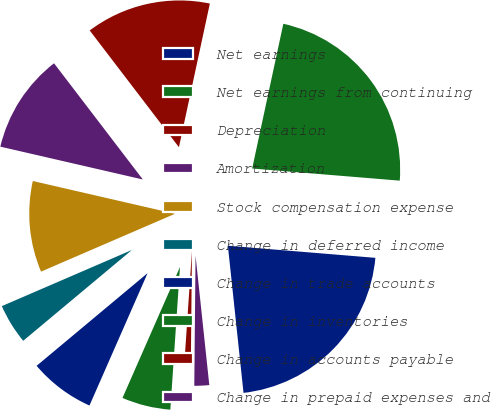Convert chart. <chart><loc_0><loc_0><loc_500><loc_500><pie_chart><fcel>Net earnings<fcel>Net earnings from continuing<fcel>Depreciation<fcel>Amortization<fcel>Stock compensation expense<fcel>Change in deferred income<fcel>Change in trade accounts<fcel>Change in inventories<fcel>Change in accounts payable<fcel>Change in prepaid expenses and<nl><fcel>22.01%<fcel>22.93%<fcel>13.76%<fcel>11.01%<fcel>10.09%<fcel>4.59%<fcel>7.34%<fcel>5.51%<fcel>0.92%<fcel>1.84%<nl></chart> 